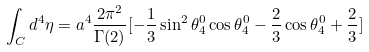<formula> <loc_0><loc_0><loc_500><loc_500>\int _ { C } { d ^ { 4 } } { \eta } = a ^ { 4 } \frac { 2 \pi ^ { 2 } } { \Gamma ( 2 ) } [ - \frac { 1 } { 3 } \sin ^ { 2 } \theta _ { 4 } ^ { 0 } \cos \theta _ { 4 } ^ { 0 } - \frac { 2 } { 3 } \cos \theta _ { 4 } ^ { 0 } + \frac { 2 } { 3 } ]</formula> 